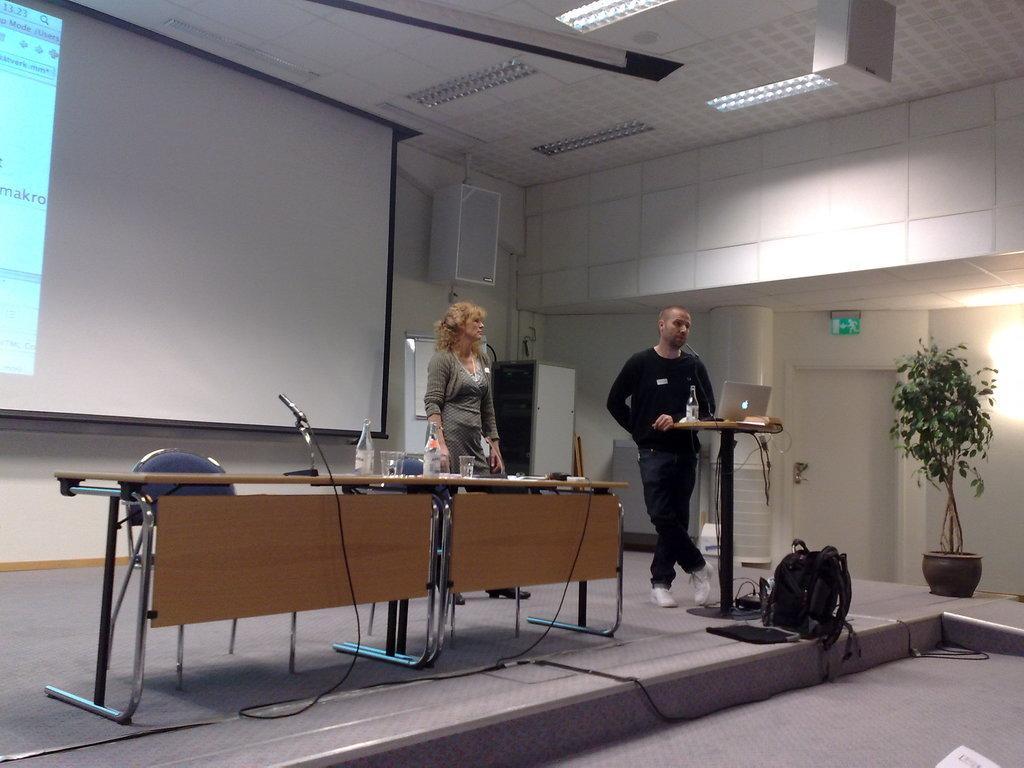Could you give a brief overview of what you see in this image? In the image I can see a man and a woman are standing on the floor. I can also see tables on which I can see microphone, laptop, bottles and some other objects. In the background I can a projector screen, lights on the ceiling, a bag, plant pot, white color door, wires and some other objects on the floor. 